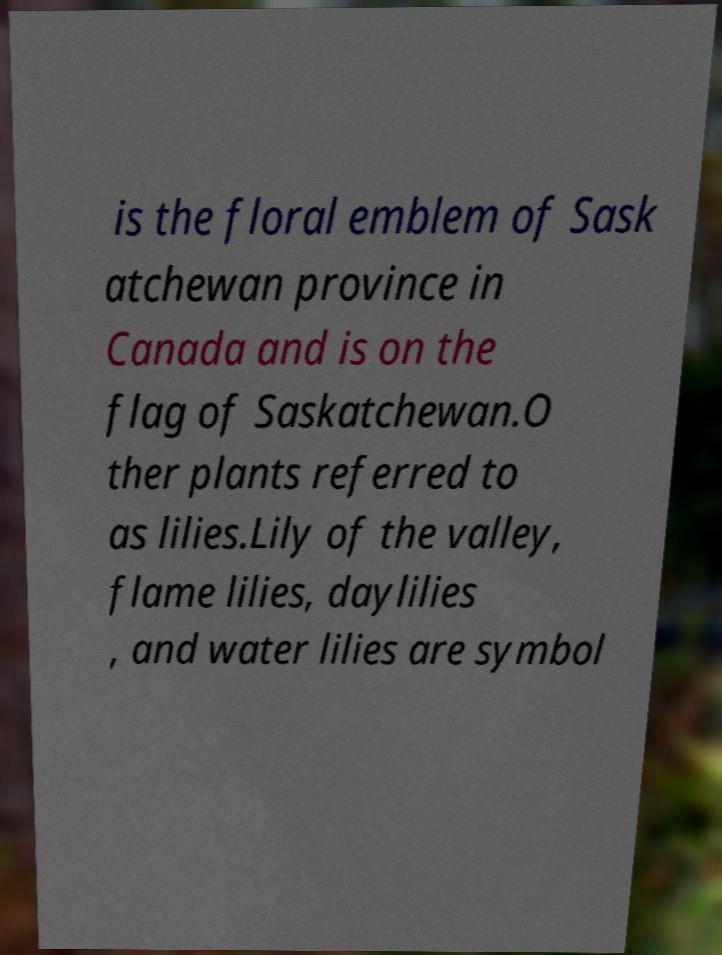There's text embedded in this image that I need extracted. Can you transcribe it verbatim? is the floral emblem of Sask atchewan province in Canada and is on the flag of Saskatchewan.O ther plants referred to as lilies.Lily of the valley, flame lilies, daylilies , and water lilies are symbol 